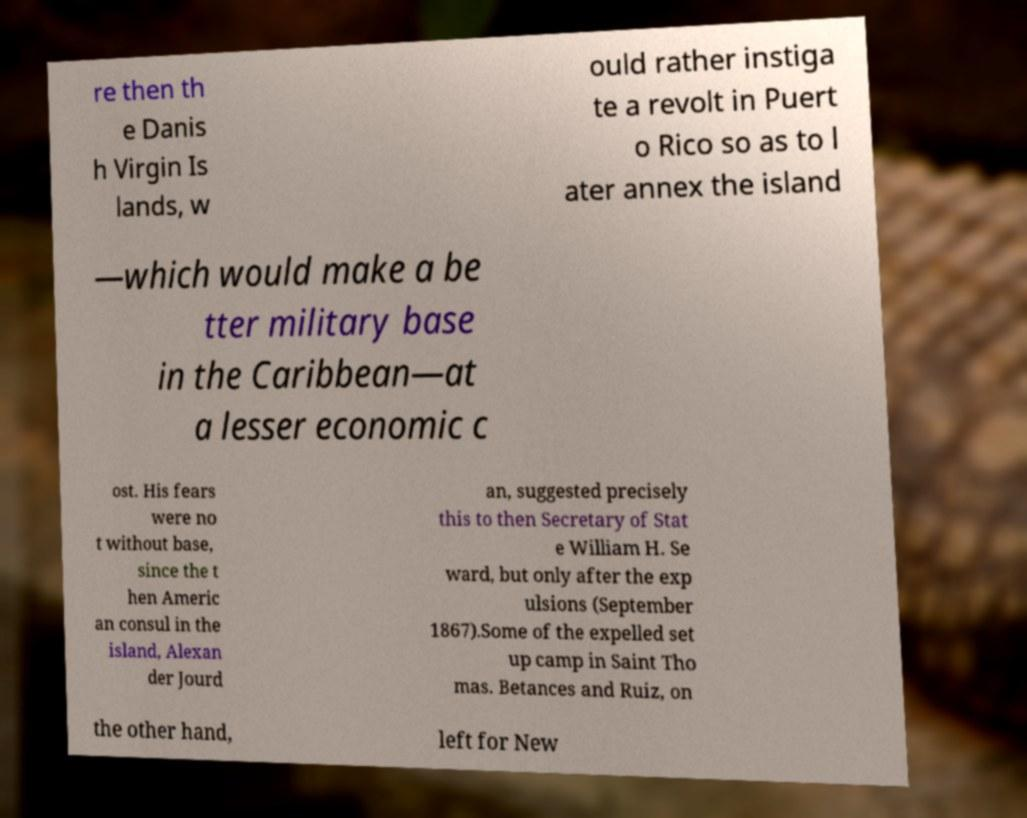Please read and relay the text visible in this image. What does it say? re then th e Danis h Virgin Is lands, w ould rather instiga te a revolt in Puert o Rico so as to l ater annex the island —which would make a be tter military base in the Caribbean—at a lesser economic c ost. His fears were no t without base, since the t hen Americ an consul in the island, Alexan der Jourd an, suggested precisely this to then Secretary of Stat e William H. Se ward, but only after the exp ulsions (September 1867).Some of the expelled set up camp in Saint Tho mas. Betances and Ruiz, on the other hand, left for New 